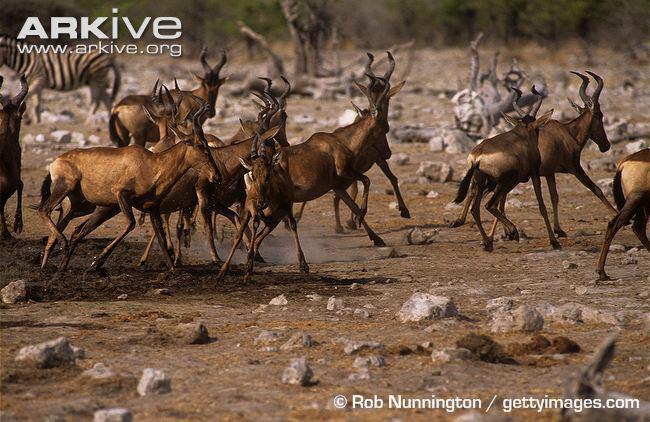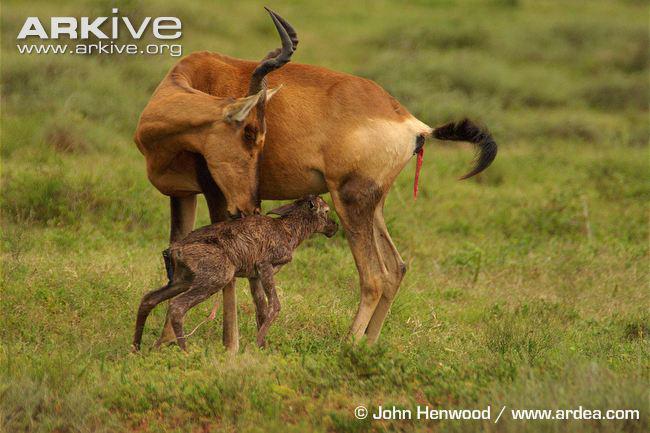The first image is the image on the left, the second image is the image on the right. For the images displayed, is the sentence "The left and right image contains a total of three antelope." factually correct? Answer yes or no. No. The first image is the image on the left, the second image is the image on the right. Given the left and right images, does the statement "The right image shows one horned animal standing behind another horned animal, with its front legs wrapped around the animal's back." hold true? Answer yes or no. No. 